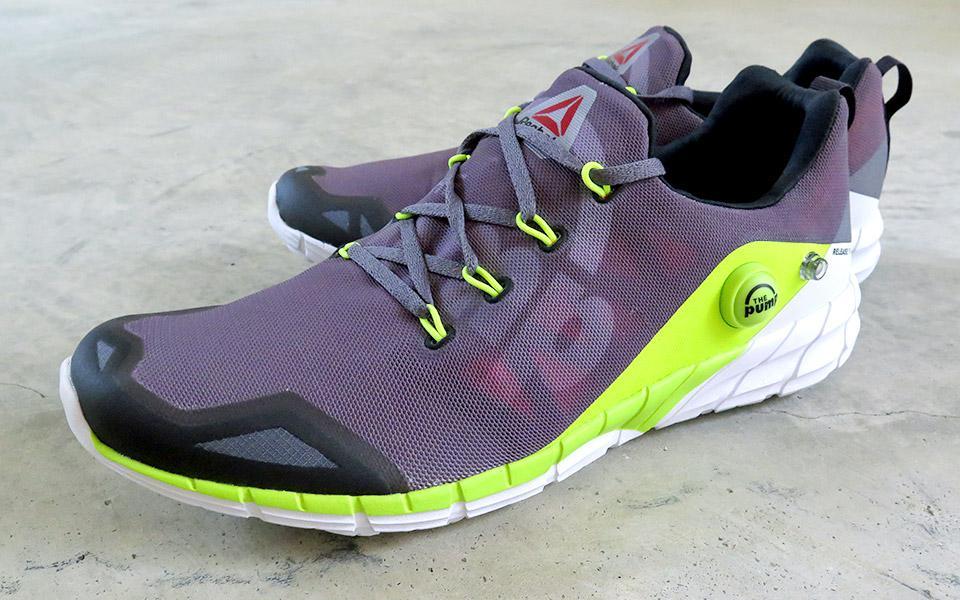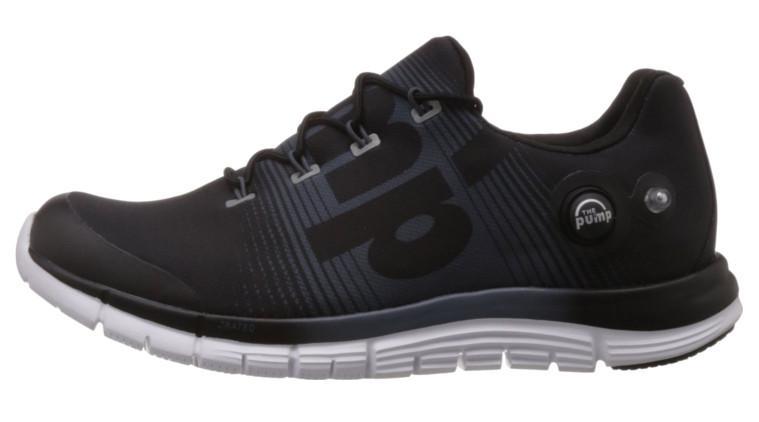The first image is the image on the left, the second image is the image on the right. For the images displayed, is the sentence "There is at least one blue sneaker" factually correct? Answer yes or no. No. The first image is the image on the left, the second image is the image on the right. For the images displayed, is the sentence "A total of four sneakers are shown in the images." factually correct? Answer yes or no. No. 